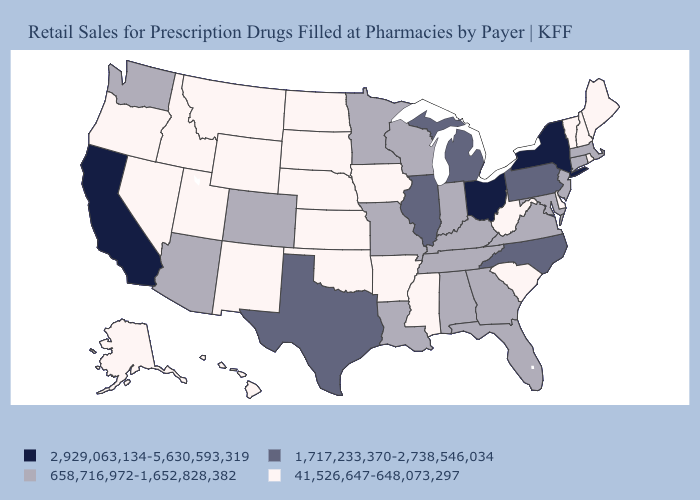Among the states that border Colorado , does Arizona have the highest value?
Give a very brief answer. Yes. Does South Carolina have the lowest value in the South?
Answer briefly. Yes. Which states have the highest value in the USA?
Short answer required. California, New York, Ohio. What is the value of North Carolina?
Quick response, please. 1,717,233,370-2,738,546,034. Which states have the highest value in the USA?
Quick response, please. California, New York, Ohio. Does New Mexico have a higher value than North Carolina?
Short answer required. No. Among the states that border Colorado , which have the lowest value?
Quick response, please. Kansas, Nebraska, New Mexico, Oklahoma, Utah, Wyoming. Name the states that have a value in the range 1,717,233,370-2,738,546,034?
Quick response, please. Illinois, Michigan, North Carolina, Pennsylvania, Texas. Among the states that border Mississippi , does Arkansas have the lowest value?
Write a very short answer. Yes. Name the states that have a value in the range 658,716,972-1,652,828,382?
Answer briefly. Alabama, Arizona, Colorado, Connecticut, Florida, Georgia, Indiana, Kentucky, Louisiana, Maryland, Massachusetts, Minnesota, Missouri, New Jersey, Tennessee, Virginia, Washington, Wisconsin. Does Alaska have the highest value in the USA?
Keep it brief. No. How many symbols are there in the legend?
Write a very short answer. 4. Does California have the same value as Michigan?
Be succinct. No. What is the value of Idaho?
Quick response, please. 41,526,647-648,073,297. What is the value of Maine?
Concise answer only. 41,526,647-648,073,297. 